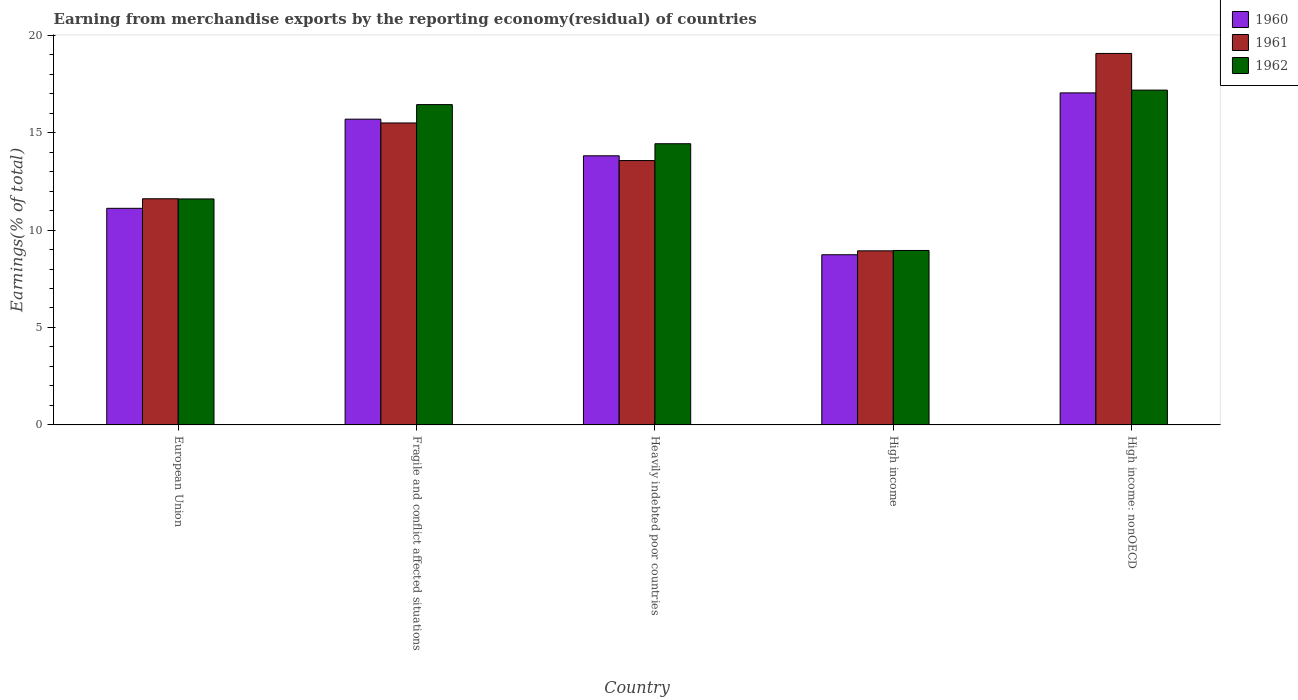Are the number of bars per tick equal to the number of legend labels?
Keep it short and to the point. Yes. Are the number of bars on each tick of the X-axis equal?
Your answer should be compact. Yes. What is the percentage of amount earned from merchandise exports in 1961 in High income?
Ensure brevity in your answer.  8.93. Across all countries, what is the maximum percentage of amount earned from merchandise exports in 1962?
Your answer should be compact. 17.18. Across all countries, what is the minimum percentage of amount earned from merchandise exports in 1962?
Provide a succinct answer. 8.95. In which country was the percentage of amount earned from merchandise exports in 1962 maximum?
Provide a succinct answer. High income: nonOECD. In which country was the percentage of amount earned from merchandise exports in 1960 minimum?
Make the answer very short. High income. What is the total percentage of amount earned from merchandise exports in 1960 in the graph?
Your answer should be very brief. 66.39. What is the difference between the percentage of amount earned from merchandise exports in 1961 in European Union and that in High income: nonOECD?
Your response must be concise. -7.46. What is the difference between the percentage of amount earned from merchandise exports in 1960 in European Union and the percentage of amount earned from merchandise exports in 1961 in High income: nonOECD?
Give a very brief answer. -7.95. What is the average percentage of amount earned from merchandise exports in 1960 per country?
Ensure brevity in your answer.  13.28. What is the difference between the percentage of amount earned from merchandise exports of/in 1962 and percentage of amount earned from merchandise exports of/in 1960 in European Union?
Provide a short and direct response. 0.48. In how many countries, is the percentage of amount earned from merchandise exports in 1962 greater than 8 %?
Offer a very short reply. 5. What is the ratio of the percentage of amount earned from merchandise exports in 1962 in European Union to that in High income: nonOECD?
Your answer should be compact. 0.67. Is the percentage of amount earned from merchandise exports in 1961 in Heavily indebted poor countries less than that in High income: nonOECD?
Your answer should be very brief. Yes. What is the difference between the highest and the second highest percentage of amount earned from merchandise exports in 1960?
Make the answer very short. 3.23. What is the difference between the highest and the lowest percentage of amount earned from merchandise exports in 1960?
Your answer should be very brief. 8.31. Is the sum of the percentage of amount earned from merchandise exports in 1962 in European Union and High income greater than the maximum percentage of amount earned from merchandise exports in 1960 across all countries?
Your answer should be compact. Yes. What does the 2nd bar from the left in High income represents?
Provide a short and direct response. 1961. Is it the case that in every country, the sum of the percentage of amount earned from merchandise exports in 1960 and percentage of amount earned from merchandise exports in 1962 is greater than the percentage of amount earned from merchandise exports in 1961?
Offer a very short reply. Yes. How many bars are there?
Offer a terse response. 15. How many countries are there in the graph?
Ensure brevity in your answer.  5. What is the difference between two consecutive major ticks on the Y-axis?
Offer a very short reply. 5. Are the values on the major ticks of Y-axis written in scientific E-notation?
Your answer should be compact. No. Does the graph contain any zero values?
Offer a very short reply. No. Does the graph contain grids?
Ensure brevity in your answer.  No. Where does the legend appear in the graph?
Provide a succinct answer. Top right. How many legend labels are there?
Provide a short and direct response. 3. What is the title of the graph?
Provide a succinct answer. Earning from merchandise exports by the reporting economy(residual) of countries. Does "1970" appear as one of the legend labels in the graph?
Make the answer very short. No. What is the label or title of the Y-axis?
Your response must be concise. Earnings(% of total). What is the Earnings(% of total) of 1960 in European Union?
Make the answer very short. 11.12. What is the Earnings(% of total) of 1961 in European Union?
Provide a succinct answer. 11.61. What is the Earnings(% of total) of 1962 in European Union?
Make the answer very short. 11.6. What is the Earnings(% of total) in 1960 in Fragile and conflict affected situations?
Your answer should be very brief. 15.69. What is the Earnings(% of total) of 1961 in Fragile and conflict affected situations?
Your response must be concise. 15.5. What is the Earnings(% of total) of 1962 in Fragile and conflict affected situations?
Your answer should be compact. 16.44. What is the Earnings(% of total) in 1960 in Heavily indebted poor countries?
Keep it short and to the point. 13.81. What is the Earnings(% of total) of 1961 in Heavily indebted poor countries?
Give a very brief answer. 13.57. What is the Earnings(% of total) in 1962 in Heavily indebted poor countries?
Your response must be concise. 14.43. What is the Earnings(% of total) in 1960 in High income?
Provide a short and direct response. 8.73. What is the Earnings(% of total) of 1961 in High income?
Offer a terse response. 8.93. What is the Earnings(% of total) in 1962 in High income?
Provide a succinct answer. 8.95. What is the Earnings(% of total) in 1960 in High income: nonOECD?
Your answer should be compact. 17.04. What is the Earnings(% of total) in 1961 in High income: nonOECD?
Offer a terse response. 19.06. What is the Earnings(% of total) in 1962 in High income: nonOECD?
Your answer should be compact. 17.18. Across all countries, what is the maximum Earnings(% of total) in 1960?
Your answer should be compact. 17.04. Across all countries, what is the maximum Earnings(% of total) of 1961?
Give a very brief answer. 19.06. Across all countries, what is the maximum Earnings(% of total) of 1962?
Give a very brief answer. 17.18. Across all countries, what is the minimum Earnings(% of total) of 1960?
Provide a succinct answer. 8.73. Across all countries, what is the minimum Earnings(% of total) of 1961?
Your response must be concise. 8.93. Across all countries, what is the minimum Earnings(% of total) in 1962?
Your answer should be very brief. 8.95. What is the total Earnings(% of total) in 1960 in the graph?
Your answer should be very brief. 66.39. What is the total Earnings(% of total) of 1961 in the graph?
Offer a very short reply. 68.67. What is the total Earnings(% of total) in 1962 in the graph?
Give a very brief answer. 68.6. What is the difference between the Earnings(% of total) in 1960 in European Union and that in Fragile and conflict affected situations?
Keep it short and to the point. -4.58. What is the difference between the Earnings(% of total) of 1961 in European Union and that in Fragile and conflict affected situations?
Your response must be concise. -3.89. What is the difference between the Earnings(% of total) in 1962 in European Union and that in Fragile and conflict affected situations?
Ensure brevity in your answer.  -4.84. What is the difference between the Earnings(% of total) in 1960 in European Union and that in Heavily indebted poor countries?
Provide a short and direct response. -2.7. What is the difference between the Earnings(% of total) of 1961 in European Union and that in Heavily indebted poor countries?
Make the answer very short. -1.96. What is the difference between the Earnings(% of total) in 1962 in European Union and that in Heavily indebted poor countries?
Make the answer very short. -2.83. What is the difference between the Earnings(% of total) of 1960 in European Union and that in High income?
Ensure brevity in your answer.  2.38. What is the difference between the Earnings(% of total) in 1961 in European Union and that in High income?
Your answer should be compact. 2.67. What is the difference between the Earnings(% of total) of 1962 in European Union and that in High income?
Offer a very short reply. 2.64. What is the difference between the Earnings(% of total) of 1960 in European Union and that in High income: nonOECD?
Provide a short and direct response. -5.92. What is the difference between the Earnings(% of total) in 1961 in European Union and that in High income: nonOECD?
Your answer should be very brief. -7.46. What is the difference between the Earnings(% of total) in 1962 in European Union and that in High income: nonOECD?
Your response must be concise. -5.59. What is the difference between the Earnings(% of total) in 1960 in Fragile and conflict affected situations and that in Heavily indebted poor countries?
Give a very brief answer. 1.88. What is the difference between the Earnings(% of total) in 1961 in Fragile and conflict affected situations and that in Heavily indebted poor countries?
Provide a short and direct response. 1.93. What is the difference between the Earnings(% of total) of 1962 in Fragile and conflict affected situations and that in Heavily indebted poor countries?
Make the answer very short. 2.01. What is the difference between the Earnings(% of total) of 1960 in Fragile and conflict affected situations and that in High income?
Provide a succinct answer. 6.96. What is the difference between the Earnings(% of total) of 1961 in Fragile and conflict affected situations and that in High income?
Your answer should be compact. 6.56. What is the difference between the Earnings(% of total) of 1962 in Fragile and conflict affected situations and that in High income?
Your answer should be very brief. 7.49. What is the difference between the Earnings(% of total) in 1960 in Fragile and conflict affected situations and that in High income: nonOECD?
Provide a succinct answer. -1.35. What is the difference between the Earnings(% of total) of 1961 in Fragile and conflict affected situations and that in High income: nonOECD?
Offer a terse response. -3.57. What is the difference between the Earnings(% of total) in 1962 in Fragile and conflict affected situations and that in High income: nonOECD?
Ensure brevity in your answer.  -0.74. What is the difference between the Earnings(% of total) of 1960 in Heavily indebted poor countries and that in High income?
Make the answer very short. 5.08. What is the difference between the Earnings(% of total) in 1961 in Heavily indebted poor countries and that in High income?
Your answer should be very brief. 4.63. What is the difference between the Earnings(% of total) of 1962 in Heavily indebted poor countries and that in High income?
Offer a very short reply. 5.48. What is the difference between the Earnings(% of total) in 1960 in Heavily indebted poor countries and that in High income: nonOECD?
Your answer should be very brief. -3.23. What is the difference between the Earnings(% of total) of 1961 in Heavily indebted poor countries and that in High income: nonOECD?
Ensure brevity in your answer.  -5.5. What is the difference between the Earnings(% of total) in 1962 in Heavily indebted poor countries and that in High income: nonOECD?
Your answer should be very brief. -2.75. What is the difference between the Earnings(% of total) in 1960 in High income and that in High income: nonOECD?
Offer a very short reply. -8.31. What is the difference between the Earnings(% of total) of 1961 in High income and that in High income: nonOECD?
Make the answer very short. -10.13. What is the difference between the Earnings(% of total) of 1962 in High income and that in High income: nonOECD?
Your answer should be very brief. -8.23. What is the difference between the Earnings(% of total) in 1960 in European Union and the Earnings(% of total) in 1961 in Fragile and conflict affected situations?
Make the answer very short. -4.38. What is the difference between the Earnings(% of total) of 1960 in European Union and the Earnings(% of total) of 1962 in Fragile and conflict affected situations?
Offer a very short reply. -5.32. What is the difference between the Earnings(% of total) of 1961 in European Union and the Earnings(% of total) of 1962 in Fragile and conflict affected situations?
Offer a terse response. -4.83. What is the difference between the Earnings(% of total) in 1960 in European Union and the Earnings(% of total) in 1961 in Heavily indebted poor countries?
Your answer should be very brief. -2.45. What is the difference between the Earnings(% of total) of 1960 in European Union and the Earnings(% of total) of 1962 in Heavily indebted poor countries?
Offer a very short reply. -3.31. What is the difference between the Earnings(% of total) of 1961 in European Union and the Earnings(% of total) of 1962 in Heavily indebted poor countries?
Give a very brief answer. -2.82. What is the difference between the Earnings(% of total) in 1960 in European Union and the Earnings(% of total) in 1961 in High income?
Make the answer very short. 2.18. What is the difference between the Earnings(% of total) in 1960 in European Union and the Earnings(% of total) in 1962 in High income?
Your answer should be very brief. 2.16. What is the difference between the Earnings(% of total) of 1961 in European Union and the Earnings(% of total) of 1962 in High income?
Offer a terse response. 2.65. What is the difference between the Earnings(% of total) in 1960 in European Union and the Earnings(% of total) in 1961 in High income: nonOECD?
Your answer should be very brief. -7.95. What is the difference between the Earnings(% of total) of 1960 in European Union and the Earnings(% of total) of 1962 in High income: nonOECD?
Make the answer very short. -6.07. What is the difference between the Earnings(% of total) of 1961 in European Union and the Earnings(% of total) of 1962 in High income: nonOECD?
Your response must be concise. -5.58. What is the difference between the Earnings(% of total) in 1960 in Fragile and conflict affected situations and the Earnings(% of total) in 1961 in Heavily indebted poor countries?
Your answer should be very brief. 2.12. What is the difference between the Earnings(% of total) of 1960 in Fragile and conflict affected situations and the Earnings(% of total) of 1962 in Heavily indebted poor countries?
Provide a succinct answer. 1.26. What is the difference between the Earnings(% of total) in 1961 in Fragile and conflict affected situations and the Earnings(% of total) in 1962 in Heavily indebted poor countries?
Give a very brief answer. 1.07. What is the difference between the Earnings(% of total) in 1960 in Fragile and conflict affected situations and the Earnings(% of total) in 1961 in High income?
Offer a very short reply. 6.76. What is the difference between the Earnings(% of total) of 1960 in Fragile and conflict affected situations and the Earnings(% of total) of 1962 in High income?
Make the answer very short. 6.74. What is the difference between the Earnings(% of total) in 1961 in Fragile and conflict affected situations and the Earnings(% of total) in 1962 in High income?
Provide a succinct answer. 6.54. What is the difference between the Earnings(% of total) in 1960 in Fragile and conflict affected situations and the Earnings(% of total) in 1961 in High income: nonOECD?
Provide a succinct answer. -3.37. What is the difference between the Earnings(% of total) in 1960 in Fragile and conflict affected situations and the Earnings(% of total) in 1962 in High income: nonOECD?
Your response must be concise. -1.49. What is the difference between the Earnings(% of total) in 1961 in Fragile and conflict affected situations and the Earnings(% of total) in 1962 in High income: nonOECD?
Your answer should be very brief. -1.69. What is the difference between the Earnings(% of total) of 1960 in Heavily indebted poor countries and the Earnings(% of total) of 1961 in High income?
Ensure brevity in your answer.  4.88. What is the difference between the Earnings(% of total) of 1960 in Heavily indebted poor countries and the Earnings(% of total) of 1962 in High income?
Provide a short and direct response. 4.86. What is the difference between the Earnings(% of total) in 1961 in Heavily indebted poor countries and the Earnings(% of total) in 1962 in High income?
Ensure brevity in your answer.  4.61. What is the difference between the Earnings(% of total) of 1960 in Heavily indebted poor countries and the Earnings(% of total) of 1961 in High income: nonOECD?
Your answer should be very brief. -5.25. What is the difference between the Earnings(% of total) in 1960 in Heavily indebted poor countries and the Earnings(% of total) in 1962 in High income: nonOECD?
Your answer should be compact. -3.37. What is the difference between the Earnings(% of total) in 1961 in Heavily indebted poor countries and the Earnings(% of total) in 1962 in High income: nonOECD?
Provide a succinct answer. -3.62. What is the difference between the Earnings(% of total) in 1960 in High income and the Earnings(% of total) in 1961 in High income: nonOECD?
Give a very brief answer. -10.33. What is the difference between the Earnings(% of total) of 1960 in High income and the Earnings(% of total) of 1962 in High income: nonOECD?
Make the answer very short. -8.45. What is the difference between the Earnings(% of total) of 1961 in High income and the Earnings(% of total) of 1962 in High income: nonOECD?
Offer a very short reply. -8.25. What is the average Earnings(% of total) of 1960 per country?
Your answer should be very brief. 13.28. What is the average Earnings(% of total) in 1961 per country?
Your answer should be very brief. 13.73. What is the average Earnings(% of total) in 1962 per country?
Provide a short and direct response. 13.72. What is the difference between the Earnings(% of total) of 1960 and Earnings(% of total) of 1961 in European Union?
Offer a terse response. -0.49. What is the difference between the Earnings(% of total) of 1960 and Earnings(% of total) of 1962 in European Union?
Provide a short and direct response. -0.48. What is the difference between the Earnings(% of total) in 1961 and Earnings(% of total) in 1962 in European Union?
Provide a short and direct response. 0.01. What is the difference between the Earnings(% of total) of 1960 and Earnings(% of total) of 1961 in Fragile and conflict affected situations?
Your answer should be very brief. 0.19. What is the difference between the Earnings(% of total) in 1960 and Earnings(% of total) in 1962 in Fragile and conflict affected situations?
Your answer should be compact. -0.75. What is the difference between the Earnings(% of total) in 1961 and Earnings(% of total) in 1962 in Fragile and conflict affected situations?
Provide a short and direct response. -0.94. What is the difference between the Earnings(% of total) in 1960 and Earnings(% of total) in 1961 in Heavily indebted poor countries?
Your response must be concise. 0.24. What is the difference between the Earnings(% of total) of 1960 and Earnings(% of total) of 1962 in Heavily indebted poor countries?
Give a very brief answer. -0.62. What is the difference between the Earnings(% of total) of 1961 and Earnings(% of total) of 1962 in Heavily indebted poor countries?
Keep it short and to the point. -0.86. What is the difference between the Earnings(% of total) of 1960 and Earnings(% of total) of 1961 in High income?
Ensure brevity in your answer.  -0.2. What is the difference between the Earnings(% of total) of 1960 and Earnings(% of total) of 1962 in High income?
Keep it short and to the point. -0.22. What is the difference between the Earnings(% of total) in 1961 and Earnings(% of total) in 1962 in High income?
Your answer should be very brief. -0.02. What is the difference between the Earnings(% of total) of 1960 and Earnings(% of total) of 1961 in High income: nonOECD?
Provide a short and direct response. -2.02. What is the difference between the Earnings(% of total) in 1960 and Earnings(% of total) in 1962 in High income: nonOECD?
Ensure brevity in your answer.  -0.14. What is the difference between the Earnings(% of total) in 1961 and Earnings(% of total) in 1962 in High income: nonOECD?
Your answer should be very brief. 1.88. What is the ratio of the Earnings(% of total) in 1960 in European Union to that in Fragile and conflict affected situations?
Provide a short and direct response. 0.71. What is the ratio of the Earnings(% of total) in 1961 in European Union to that in Fragile and conflict affected situations?
Keep it short and to the point. 0.75. What is the ratio of the Earnings(% of total) in 1962 in European Union to that in Fragile and conflict affected situations?
Offer a terse response. 0.71. What is the ratio of the Earnings(% of total) in 1960 in European Union to that in Heavily indebted poor countries?
Offer a very short reply. 0.8. What is the ratio of the Earnings(% of total) of 1961 in European Union to that in Heavily indebted poor countries?
Your response must be concise. 0.86. What is the ratio of the Earnings(% of total) of 1962 in European Union to that in Heavily indebted poor countries?
Your response must be concise. 0.8. What is the ratio of the Earnings(% of total) of 1960 in European Union to that in High income?
Provide a short and direct response. 1.27. What is the ratio of the Earnings(% of total) in 1961 in European Union to that in High income?
Ensure brevity in your answer.  1.3. What is the ratio of the Earnings(% of total) of 1962 in European Union to that in High income?
Offer a terse response. 1.3. What is the ratio of the Earnings(% of total) in 1960 in European Union to that in High income: nonOECD?
Provide a short and direct response. 0.65. What is the ratio of the Earnings(% of total) in 1961 in European Union to that in High income: nonOECD?
Your answer should be very brief. 0.61. What is the ratio of the Earnings(% of total) in 1962 in European Union to that in High income: nonOECD?
Provide a succinct answer. 0.67. What is the ratio of the Earnings(% of total) in 1960 in Fragile and conflict affected situations to that in Heavily indebted poor countries?
Give a very brief answer. 1.14. What is the ratio of the Earnings(% of total) in 1961 in Fragile and conflict affected situations to that in Heavily indebted poor countries?
Your response must be concise. 1.14. What is the ratio of the Earnings(% of total) in 1962 in Fragile and conflict affected situations to that in Heavily indebted poor countries?
Give a very brief answer. 1.14. What is the ratio of the Earnings(% of total) in 1960 in Fragile and conflict affected situations to that in High income?
Your answer should be very brief. 1.8. What is the ratio of the Earnings(% of total) of 1961 in Fragile and conflict affected situations to that in High income?
Provide a succinct answer. 1.73. What is the ratio of the Earnings(% of total) of 1962 in Fragile and conflict affected situations to that in High income?
Keep it short and to the point. 1.84. What is the ratio of the Earnings(% of total) of 1960 in Fragile and conflict affected situations to that in High income: nonOECD?
Provide a succinct answer. 0.92. What is the ratio of the Earnings(% of total) in 1961 in Fragile and conflict affected situations to that in High income: nonOECD?
Offer a terse response. 0.81. What is the ratio of the Earnings(% of total) in 1962 in Fragile and conflict affected situations to that in High income: nonOECD?
Make the answer very short. 0.96. What is the ratio of the Earnings(% of total) in 1960 in Heavily indebted poor countries to that in High income?
Give a very brief answer. 1.58. What is the ratio of the Earnings(% of total) of 1961 in Heavily indebted poor countries to that in High income?
Give a very brief answer. 1.52. What is the ratio of the Earnings(% of total) of 1962 in Heavily indebted poor countries to that in High income?
Your answer should be very brief. 1.61. What is the ratio of the Earnings(% of total) of 1960 in Heavily indebted poor countries to that in High income: nonOECD?
Offer a terse response. 0.81. What is the ratio of the Earnings(% of total) of 1961 in Heavily indebted poor countries to that in High income: nonOECD?
Offer a terse response. 0.71. What is the ratio of the Earnings(% of total) of 1962 in Heavily indebted poor countries to that in High income: nonOECD?
Your answer should be very brief. 0.84. What is the ratio of the Earnings(% of total) of 1960 in High income to that in High income: nonOECD?
Provide a succinct answer. 0.51. What is the ratio of the Earnings(% of total) of 1961 in High income to that in High income: nonOECD?
Your answer should be compact. 0.47. What is the ratio of the Earnings(% of total) of 1962 in High income to that in High income: nonOECD?
Provide a short and direct response. 0.52. What is the difference between the highest and the second highest Earnings(% of total) in 1960?
Offer a very short reply. 1.35. What is the difference between the highest and the second highest Earnings(% of total) of 1961?
Offer a very short reply. 3.57. What is the difference between the highest and the second highest Earnings(% of total) of 1962?
Keep it short and to the point. 0.74. What is the difference between the highest and the lowest Earnings(% of total) of 1960?
Your response must be concise. 8.31. What is the difference between the highest and the lowest Earnings(% of total) in 1961?
Keep it short and to the point. 10.13. What is the difference between the highest and the lowest Earnings(% of total) in 1962?
Give a very brief answer. 8.23. 